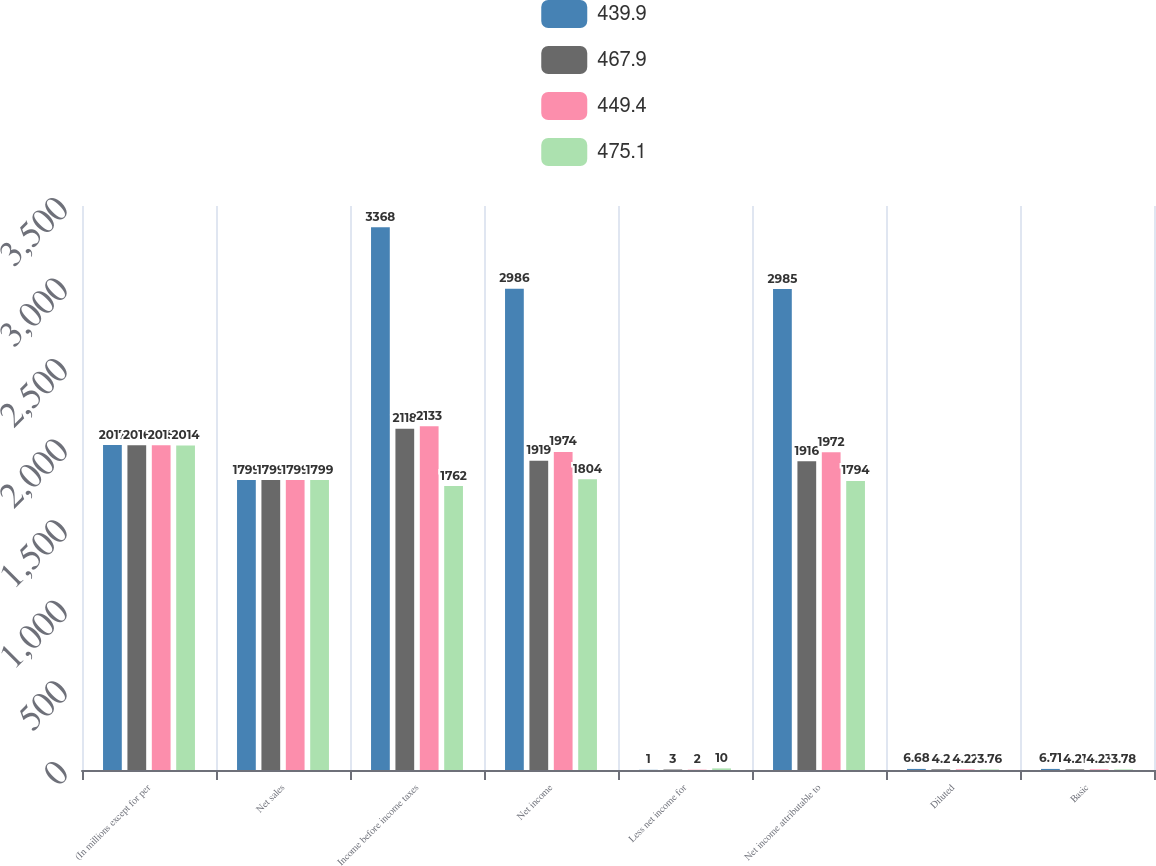<chart> <loc_0><loc_0><loc_500><loc_500><stacked_bar_chart><ecel><fcel>(In millions except for per<fcel>Net sales<fcel>Income before income taxes<fcel>Net income<fcel>Less net income for<fcel>Net income attributable to<fcel>Diluted<fcel>Basic<nl><fcel>439.9<fcel>2017<fcel>1799<fcel>3368<fcel>2986<fcel>1<fcel>2985<fcel>6.68<fcel>6.71<nl><fcel>467.9<fcel>2016<fcel>1799<fcel>2118<fcel>1919<fcel>3<fcel>1916<fcel>4.2<fcel>4.21<nl><fcel>449.4<fcel>2015<fcel>1799<fcel>2133<fcel>1974<fcel>2<fcel>1972<fcel>4.22<fcel>4.23<nl><fcel>475.1<fcel>2014<fcel>1799<fcel>1762<fcel>1804<fcel>10<fcel>1794<fcel>3.76<fcel>3.78<nl></chart> 